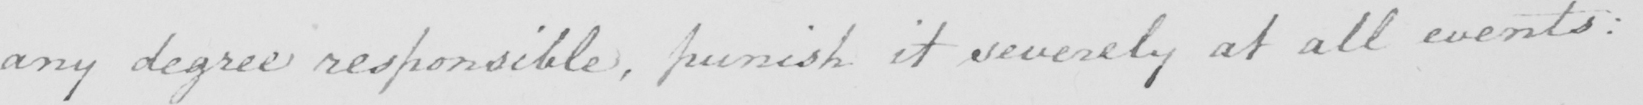What text is written in this handwritten line? any degree responsible , punish it severely at all events : 